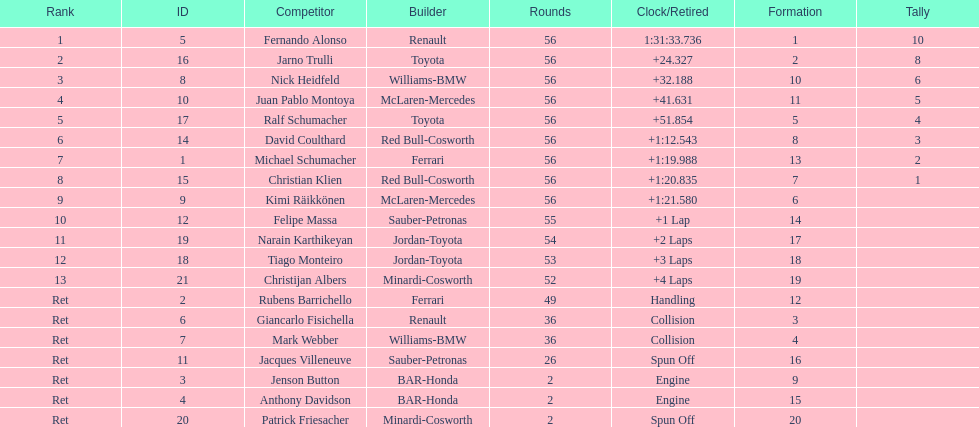What were the total number of laps completed by the 1st position winner? 56. 